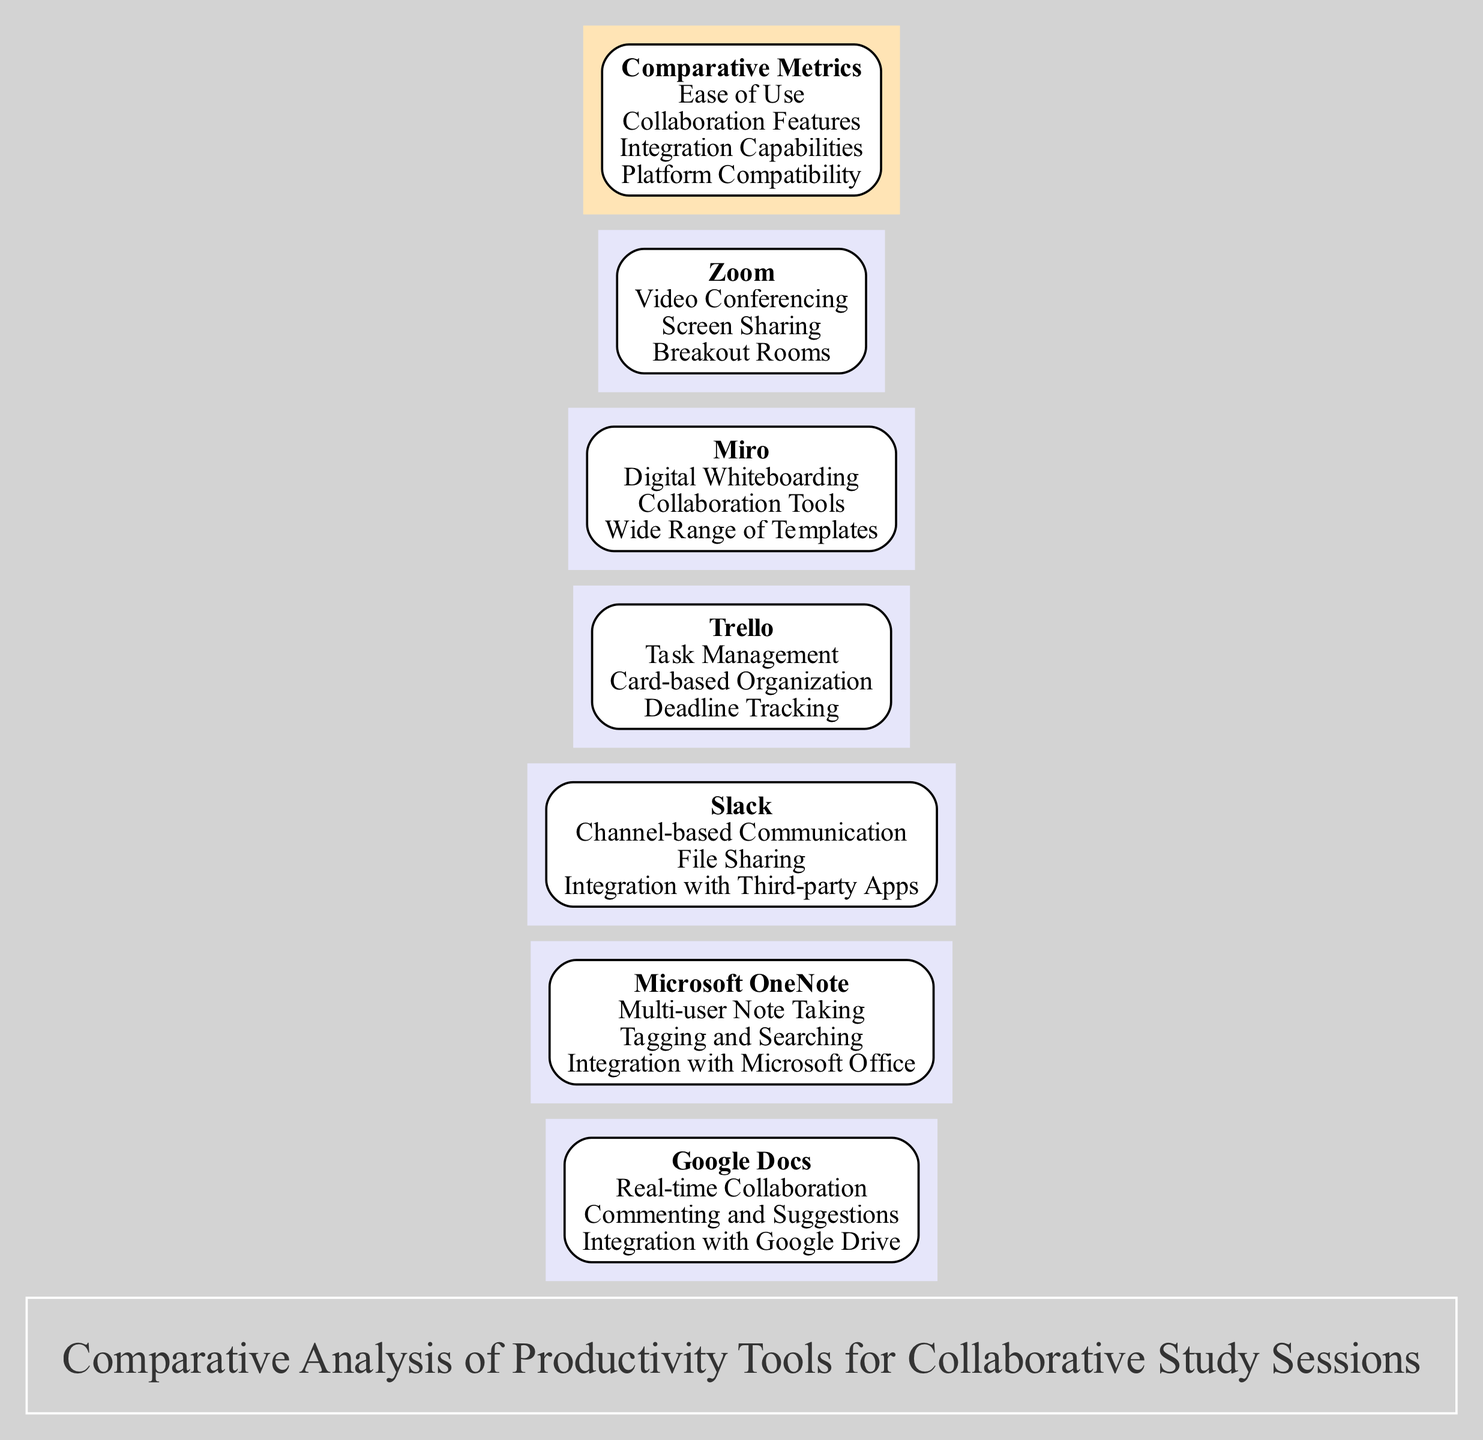What productivity tool features real-time collaboration? According to the block for Google Docs, it lists "Real-time Collaboration" as one of its key features. This feature is specifically mentioned under the Google Docs block, making it the direct answer.
Answer: Real-time Collaboration Which productivity tool offers task management? Looking at the Trello block, it explicitly states "Task Management" as one of its key features. Thus, Trello is the answer in this context.
Answer: Trello How many productivity tools are compared in this diagram? By counting the blocks listed under the title in the diagram, there are a total of six blocks, each representing a different productivity tool.
Answer: 6 Which tool integrates with Microsoft Office? The block for Microsoft OneNote clearly shows "Integration with Microsoft Office" as one of its features. This direct mention identifies the tool associated with this capability.
Answer: Microsoft OneNote Among the listed tools, which one has digital whiteboarding as a feature? The Miro block indicates "Digital Whiteboarding" as one of its features, explicitly identifying this tool's unique offering.
Answer: Miro Which productivity tool includes video conferencing capabilities? The Zoom block states "Video Conferencing" as one of its primary features, thus directly answering which tool provides this capability.
Answer: Zoom What is the second comparative metric listed in the diagram? The metrics block lists "Ease of Use" as the first metric and "Collaboration Features" as the second one. Therefore, identifying the position shows the required answer.
Answer: Collaboration Features Which tool is associated with channel-based communication? According to the Slack block, it lists "Channel-based Communication" as one of its features, linking this capability directly to Slack.
Answer: Slack Which two tools integrate with third-party apps? Both Slack and Trello have features that mention integration with third-party apps, making them the two tools that can be identified based on this attribute.
Answer: Slack, Trello 